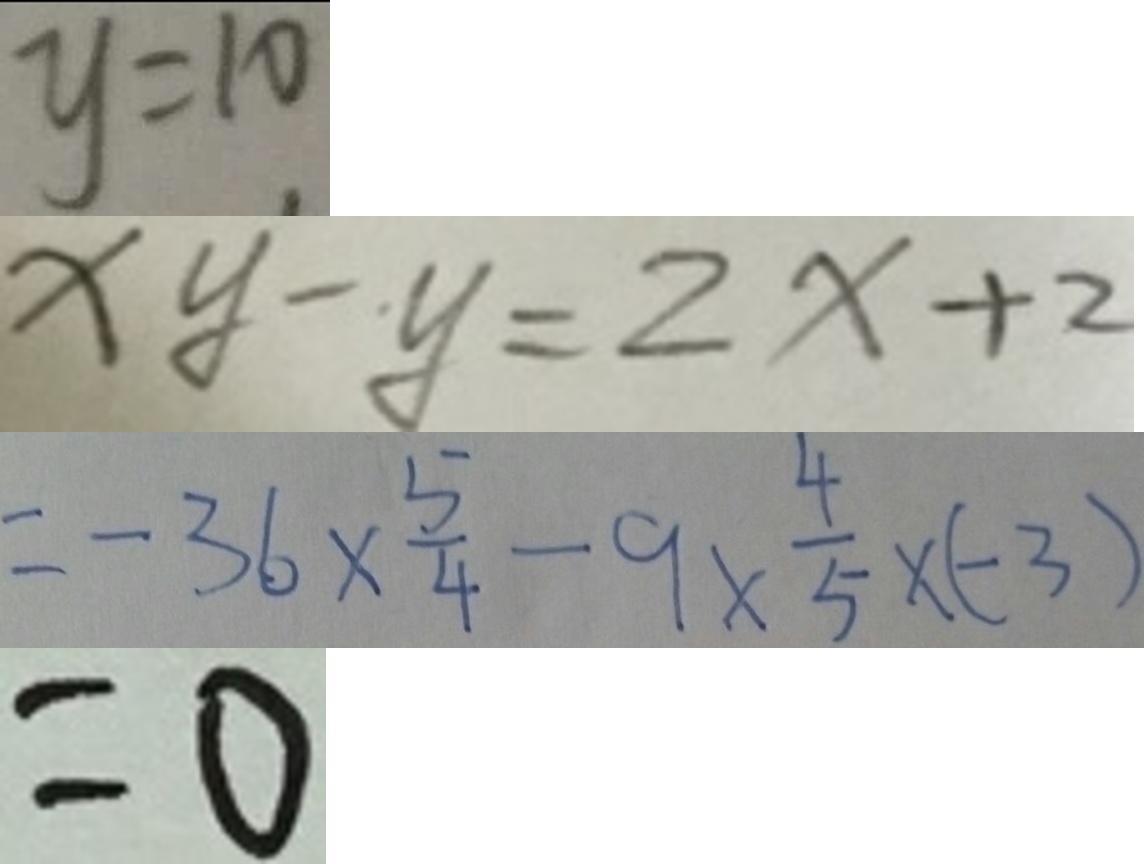<formula> <loc_0><loc_0><loc_500><loc_500>y = 1 0 
 x y - y = 2 x + 2 
 = - 3 6 \times \frac { 5 } { 4 } - 9 \times \frac { 4 } { 5 } \times ( - 3 ) 
 = 0</formula> 